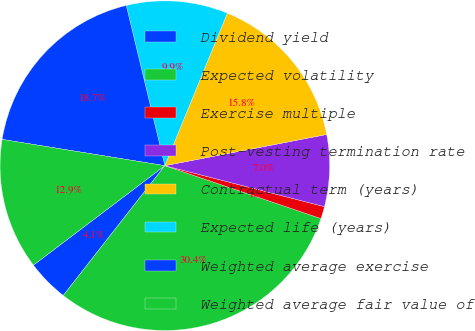Convert chart to OTSL. <chart><loc_0><loc_0><loc_500><loc_500><pie_chart><fcel>Dividend yield<fcel>Expected volatility<fcel>Exercise multiple<fcel>Post-vesting termination rate<fcel>Contractual term (years)<fcel>Expected life (years)<fcel>Weighted average exercise<fcel>Weighted average fair value of<nl><fcel>4.12%<fcel>30.37%<fcel>1.2%<fcel>7.03%<fcel>15.78%<fcel>9.95%<fcel>18.69%<fcel>12.86%<nl></chart> 